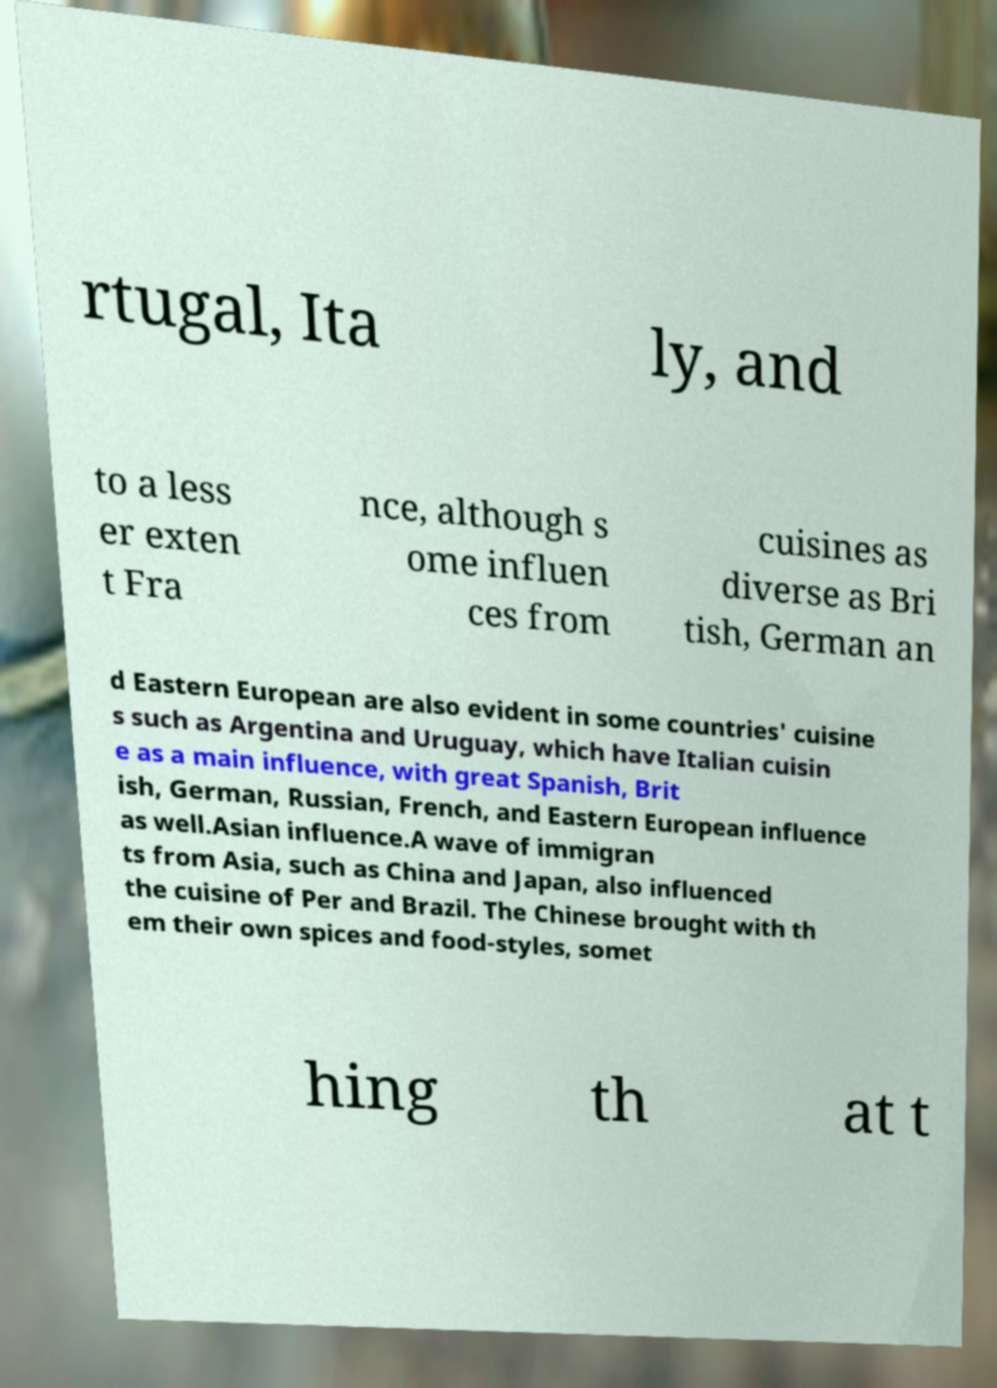There's text embedded in this image that I need extracted. Can you transcribe it verbatim? rtugal, Ita ly, and to a less er exten t Fra nce, although s ome influen ces from cuisines as diverse as Bri tish, German an d Eastern European are also evident in some countries' cuisine s such as Argentina and Uruguay, which have Italian cuisin e as a main influence, with great Spanish, Brit ish, German, Russian, French, and Eastern European influence as well.Asian influence.A wave of immigran ts from Asia, such as China and Japan, also influenced the cuisine of Per and Brazil. The Chinese brought with th em their own spices and food-styles, somet hing th at t 